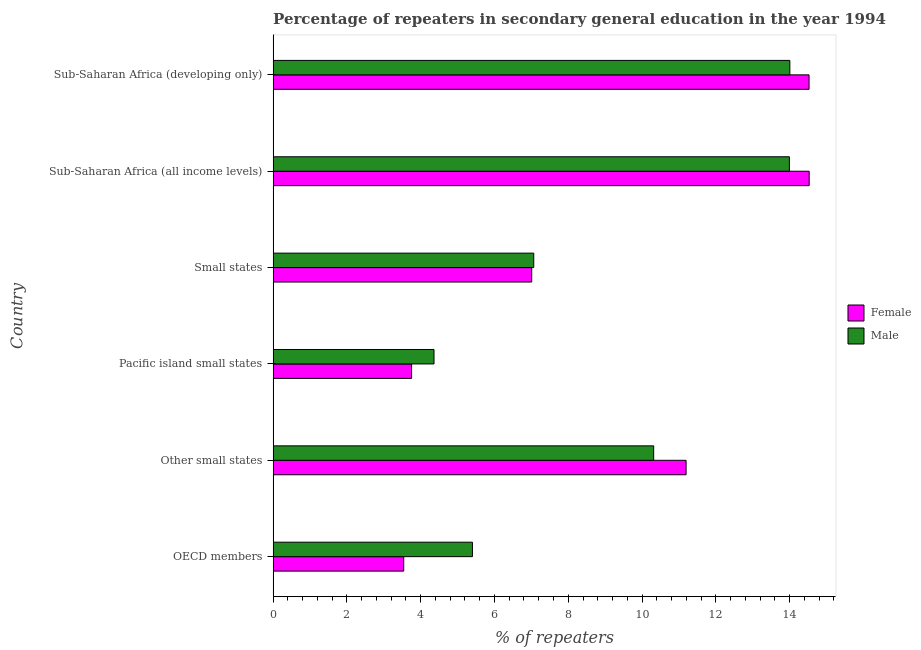How many different coloured bars are there?
Your answer should be compact. 2. How many groups of bars are there?
Provide a short and direct response. 6. Are the number of bars per tick equal to the number of legend labels?
Your answer should be very brief. Yes. How many bars are there on the 3rd tick from the top?
Provide a short and direct response. 2. How many bars are there on the 6th tick from the bottom?
Give a very brief answer. 2. What is the label of the 1st group of bars from the top?
Offer a terse response. Sub-Saharan Africa (developing only). In how many cases, is the number of bars for a given country not equal to the number of legend labels?
Your answer should be compact. 0. What is the percentage of female repeaters in Sub-Saharan Africa (all income levels)?
Provide a succinct answer. 14.53. Across all countries, what is the maximum percentage of female repeaters?
Your response must be concise. 14.53. Across all countries, what is the minimum percentage of female repeaters?
Your answer should be very brief. 3.54. In which country was the percentage of male repeaters maximum?
Your answer should be compact. Sub-Saharan Africa (developing only). In which country was the percentage of female repeaters minimum?
Offer a terse response. OECD members. What is the total percentage of female repeaters in the graph?
Keep it short and to the point. 54.56. What is the difference between the percentage of male repeaters in Other small states and that in Pacific island small states?
Your answer should be very brief. 5.95. What is the difference between the percentage of male repeaters in Sub-Saharan Africa (all income levels) and the percentage of female repeaters in Other small states?
Make the answer very short. 2.8. What is the average percentage of male repeaters per country?
Your answer should be very brief. 9.19. What is the difference between the percentage of female repeaters and percentage of male repeaters in Pacific island small states?
Your answer should be compact. -0.61. In how many countries, is the percentage of female repeaters greater than 11.2 %?
Offer a terse response. 2. What is the ratio of the percentage of female repeaters in Small states to that in Sub-Saharan Africa (all income levels)?
Provide a succinct answer. 0.48. Is the percentage of female repeaters in Other small states less than that in Small states?
Keep it short and to the point. No. Is the difference between the percentage of male repeaters in OECD members and Small states greater than the difference between the percentage of female repeaters in OECD members and Small states?
Ensure brevity in your answer.  Yes. What is the difference between the highest and the second highest percentage of male repeaters?
Offer a very short reply. 0.01. What is the difference between the highest and the lowest percentage of male repeaters?
Your answer should be compact. 9.65. In how many countries, is the percentage of male repeaters greater than the average percentage of male repeaters taken over all countries?
Provide a succinct answer. 3. Is the sum of the percentage of male repeaters in OECD members and Other small states greater than the maximum percentage of female repeaters across all countries?
Your answer should be very brief. Yes. Are all the bars in the graph horizontal?
Keep it short and to the point. Yes. How many countries are there in the graph?
Ensure brevity in your answer.  6. Does the graph contain any zero values?
Provide a short and direct response. No. Where does the legend appear in the graph?
Give a very brief answer. Center right. How many legend labels are there?
Your response must be concise. 2. What is the title of the graph?
Your response must be concise. Percentage of repeaters in secondary general education in the year 1994. Does "Total Population" appear as one of the legend labels in the graph?
Give a very brief answer. No. What is the label or title of the X-axis?
Ensure brevity in your answer.  % of repeaters. What is the label or title of the Y-axis?
Provide a short and direct response. Country. What is the % of repeaters of Female in OECD members?
Keep it short and to the point. 3.54. What is the % of repeaters of Male in OECD members?
Your response must be concise. 5.4. What is the % of repeaters of Female in Other small states?
Your answer should be very brief. 11.19. What is the % of repeaters in Male in Other small states?
Provide a short and direct response. 10.32. What is the % of repeaters of Female in Pacific island small states?
Make the answer very short. 3.75. What is the % of repeaters of Male in Pacific island small states?
Provide a succinct answer. 4.36. What is the % of repeaters of Female in Small states?
Offer a very short reply. 7.01. What is the % of repeaters in Male in Small states?
Give a very brief answer. 7.07. What is the % of repeaters in Female in Sub-Saharan Africa (all income levels)?
Keep it short and to the point. 14.53. What is the % of repeaters of Male in Sub-Saharan Africa (all income levels)?
Offer a very short reply. 13.99. What is the % of repeaters of Female in Sub-Saharan Africa (developing only)?
Give a very brief answer. 14.53. What is the % of repeaters of Male in Sub-Saharan Africa (developing only)?
Give a very brief answer. 14.01. Across all countries, what is the maximum % of repeaters in Female?
Provide a succinct answer. 14.53. Across all countries, what is the maximum % of repeaters of Male?
Offer a terse response. 14.01. Across all countries, what is the minimum % of repeaters in Female?
Make the answer very short. 3.54. Across all countries, what is the minimum % of repeaters of Male?
Offer a terse response. 4.36. What is the total % of repeaters in Female in the graph?
Ensure brevity in your answer.  54.56. What is the total % of repeaters of Male in the graph?
Ensure brevity in your answer.  55.15. What is the difference between the % of repeaters in Female in OECD members and that in Other small states?
Give a very brief answer. -7.65. What is the difference between the % of repeaters in Male in OECD members and that in Other small states?
Your answer should be very brief. -4.91. What is the difference between the % of repeaters in Female in OECD members and that in Pacific island small states?
Provide a succinct answer. -0.21. What is the difference between the % of repeaters of Male in OECD members and that in Pacific island small states?
Give a very brief answer. 1.04. What is the difference between the % of repeaters of Female in OECD members and that in Small states?
Provide a succinct answer. -3.47. What is the difference between the % of repeaters of Male in OECD members and that in Small states?
Ensure brevity in your answer.  -1.66. What is the difference between the % of repeaters in Female in OECD members and that in Sub-Saharan Africa (all income levels)?
Offer a terse response. -10.99. What is the difference between the % of repeaters of Male in OECD members and that in Sub-Saharan Africa (all income levels)?
Provide a succinct answer. -8.59. What is the difference between the % of repeaters of Female in OECD members and that in Sub-Saharan Africa (developing only)?
Your answer should be compact. -10.99. What is the difference between the % of repeaters in Male in OECD members and that in Sub-Saharan Africa (developing only)?
Your response must be concise. -8.6. What is the difference between the % of repeaters of Female in Other small states and that in Pacific island small states?
Your answer should be compact. 7.44. What is the difference between the % of repeaters of Male in Other small states and that in Pacific island small states?
Offer a terse response. 5.95. What is the difference between the % of repeaters in Female in Other small states and that in Small states?
Your response must be concise. 4.18. What is the difference between the % of repeaters in Male in Other small states and that in Small states?
Offer a terse response. 3.25. What is the difference between the % of repeaters in Female in Other small states and that in Sub-Saharan Africa (all income levels)?
Give a very brief answer. -3.34. What is the difference between the % of repeaters in Male in Other small states and that in Sub-Saharan Africa (all income levels)?
Your answer should be compact. -3.68. What is the difference between the % of repeaters of Female in Other small states and that in Sub-Saharan Africa (developing only)?
Your answer should be very brief. -3.33. What is the difference between the % of repeaters in Male in Other small states and that in Sub-Saharan Africa (developing only)?
Your answer should be very brief. -3.69. What is the difference between the % of repeaters of Female in Pacific island small states and that in Small states?
Your answer should be compact. -3.26. What is the difference between the % of repeaters in Male in Pacific island small states and that in Small states?
Your answer should be compact. -2.7. What is the difference between the % of repeaters in Female in Pacific island small states and that in Sub-Saharan Africa (all income levels)?
Your response must be concise. -10.78. What is the difference between the % of repeaters in Male in Pacific island small states and that in Sub-Saharan Africa (all income levels)?
Your answer should be very brief. -9.63. What is the difference between the % of repeaters in Female in Pacific island small states and that in Sub-Saharan Africa (developing only)?
Make the answer very short. -10.77. What is the difference between the % of repeaters in Male in Pacific island small states and that in Sub-Saharan Africa (developing only)?
Provide a succinct answer. -9.65. What is the difference between the % of repeaters in Female in Small states and that in Sub-Saharan Africa (all income levels)?
Offer a very short reply. -7.52. What is the difference between the % of repeaters of Male in Small states and that in Sub-Saharan Africa (all income levels)?
Ensure brevity in your answer.  -6.93. What is the difference between the % of repeaters in Female in Small states and that in Sub-Saharan Africa (developing only)?
Your response must be concise. -7.52. What is the difference between the % of repeaters in Male in Small states and that in Sub-Saharan Africa (developing only)?
Offer a very short reply. -6.94. What is the difference between the % of repeaters of Female in Sub-Saharan Africa (all income levels) and that in Sub-Saharan Africa (developing only)?
Keep it short and to the point. 0. What is the difference between the % of repeaters in Male in Sub-Saharan Africa (all income levels) and that in Sub-Saharan Africa (developing only)?
Provide a short and direct response. -0.01. What is the difference between the % of repeaters in Female in OECD members and the % of repeaters in Male in Other small states?
Provide a short and direct response. -6.78. What is the difference between the % of repeaters of Female in OECD members and the % of repeaters of Male in Pacific island small states?
Provide a succinct answer. -0.82. What is the difference between the % of repeaters of Female in OECD members and the % of repeaters of Male in Small states?
Keep it short and to the point. -3.52. What is the difference between the % of repeaters of Female in OECD members and the % of repeaters of Male in Sub-Saharan Africa (all income levels)?
Keep it short and to the point. -10.45. What is the difference between the % of repeaters in Female in OECD members and the % of repeaters in Male in Sub-Saharan Africa (developing only)?
Provide a short and direct response. -10.47. What is the difference between the % of repeaters of Female in Other small states and the % of repeaters of Male in Pacific island small states?
Your response must be concise. 6.83. What is the difference between the % of repeaters of Female in Other small states and the % of repeaters of Male in Small states?
Provide a succinct answer. 4.13. What is the difference between the % of repeaters in Female in Other small states and the % of repeaters in Male in Sub-Saharan Africa (all income levels)?
Ensure brevity in your answer.  -2.8. What is the difference between the % of repeaters of Female in Other small states and the % of repeaters of Male in Sub-Saharan Africa (developing only)?
Offer a very short reply. -2.81. What is the difference between the % of repeaters of Female in Pacific island small states and the % of repeaters of Male in Small states?
Make the answer very short. -3.31. What is the difference between the % of repeaters of Female in Pacific island small states and the % of repeaters of Male in Sub-Saharan Africa (all income levels)?
Your answer should be compact. -10.24. What is the difference between the % of repeaters in Female in Pacific island small states and the % of repeaters in Male in Sub-Saharan Africa (developing only)?
Make the answer very short. -10.25. What is the difference between the % of repeaters of Female in Small states and the % of repeaters of Male in Sub-Saharan Africa (all income levels)?
Offer a very short reply. -6.98. What is the difference between the % of repeaters of Female in Small states and the % of repeaters of Male in Sub-Saharan Africa (developing only)?
Your answer should be very brief. -7. What is the difference between the % of repeaters in Female in Sub-Saharan Africa (all income levels) and the % of repeaters in Male in Sub-Saharan Africa (developing only)?
Offer a terse response. 0.52. What is the average % of repeaters in Female per country?
Offer a very short reply. 9.09. What is the average % of repeaters of Male per country?
Offer a terse response. 9.19. What is the difference between the % of repeaters in Female and % of repeaters in Male in OECD members?
Offer a very short reply. -1.86. What is the difference between the % of repeaters of Female and % of repeaters of Male in Other small states?
Ensure brevity in your answer.  0.88. What is the difference between the % of repeaters of Female and % of repeaters of Male in Pacific island small states?
Your answer should be very brief. -0.61. What is the difference between the % of repeaters of Female and % of repeaters of Male in Small states?
Your answer should be compact. -0.06. What is the difference between the % of repeaters in Female and % of repeaters in Male in Sub-Saharan Africa (all income levels)?
Keep it short and to the point. 0.54. What is the difference between the % of repeaters in Female and % of repeaters in Male in Sub-Saharan Africa (developing only)?
Give a very brief answer. 0.52. What is the ratio of the % of repeaters in Female in OECD members to that in Other small states?
Provide a succinct answer. 0.32. What is the ratio of the % of repeaters in Male in OECD members to that in Other small states?
Your response must be concise. 0.52. What is the ratio of the % of repeaters of Female in OECD members to that in Pacific island small states?
Keep it short and to the point. 0.94. What is the ratio of the % of repeaters of Male in OECD members to that in Pacific island small states?
Give a very brief answer. 1.24. What is the ratio of the % of repeaters in Female in OECD members to that in Small states?
Offer a very short reply. 0.51. What is the ratio of the % of repeaters of Male in OECD members to that in Small states?
Your answer should be compact. 0.76. What is the ratio of the % of repeaters in Female in OECD members to that in Sub-Saharan Africa (all income levels)?
Give a very brief answer. 0.24. What is the ratio of the % of repeaters of Male in OECD members to that in Sub-Saharan Africa (all income levels)?
Give a very brief answer. 0.39. What is the ratio of the % of repeaters in Female in OECD members to that in Sub-Saharan Africa (developing only)?
Provide a succinct answer. 0.24. What is the ratio of the % of repeaters in Male in OECD members to that in Sub-Saharan Africa (developing only)?
Give a very brief answer. 0.39. What is the ratio of the % of repeaters of Female in Other small states to that in Pacific island small states?
Offer a terse response. 2.98. What is the ratio of the % of repeaters of Male in Other small states to that in Pacific island small states?
Offer a terse response. 2.37. What is the ratio of the % of repeaters of Female in Other small states to that in Small states?
Make the answer very short. 1.6. What is the ratio of the % of repeaters in Male in Other small states to that in Small states?
Make the answer very short. 1.46. What is the ratio of the % of repeaters of Female in Other small states to that in Sub-Saharan Africa (all income levels)?
Offer a very short reply. 0.77. What is the ratio of the % of repeaters of Male in Other small states to that in Sub-Saharan Africa (all income levels)?
Your answer should be compact. 0.74. What is the ratio of the % of repeaters in Female in Other small states to that in Sub-Saharan Africa (developing only)?
Your answer should be compact. 0.77. What is the ratio of the % of repeaters of Male in Other small states to that in Sub-Saharan Africa (developing only)?
Your answer should be compact. 0.74. What is the ratio of the % of repeaters of Female in Pacific island small states to that in Small states?
Your response must be concise. 0.54. What is the ratio of the % of repeaters of Male in Pacific island small states to that in Small states?
Make the answer very short. 0.62. What is the ratio of the % of repeaters in Female in Pacific island small states to that in Sub-Saharan Africa (all income levels)?
Your answer should be very brief. 0.26. What is the ratio of the % of repeaters in Male in Pacific island small states to that in Sub-Saharan Africa (all income levels)?
Make the answer very short. 0.31. What is the ratio of the % of repeaters in Female in Pacific island small states to that in Sub-Saharan Africa (developing only)?
Your answer should be very brief. 0.26. What is the ratio of the % of repeaters in Male in Pacific island small states to that in Sub-Saharan Africa (developing only)?
Give a very brief answer. 0.31. What is the ratio of the % of repeaters of Female in Small states to that in Sub-Saharan Africa (all income levels)?
Your answer should be very brief. 0.48. What is the ratio of the % of repeaters of Male in Small states to that in Sub-Saharan Africa (all income levels)?
Offer a very short reply. 0.5. What is the ratio of the % of repeaters in Female in Small states to that in Sub-Saharan Africa (developing only)?
Give a very brief answer. 0.48. What is the ratio of the % of repeaters in Male in Small states to that in Sub-Saharan Africa (developing only)?
Your response must be concise. 0.5. What is the ratio of the % of repeaters in Female in Sub-Saharan Africa (all income levels) to that in Sub-Saharan Africa (developing only)?
Provide a short and direct response. 1. What is the ratio of the % of repeaters of Male in Sub-Saharan Africa (all income levels) to that in Sub-Saharan Africa (developing only)?
Ensure brevity in your answer.  1. What is the difference between the highest and the second highest % of repeaters of Female?
Offer a very short reply. 0. What is the difference between the highest and the second highest % of repeaters in Male?
Give a very brief answer. 0.01. What is the difference between the highest and the lowest % of repeaters in Female?
Your response must be concise. 10.99. What is the difference between the highest and the lowest % of repeaters of Male?
Your answer should be very brief. 9.65. 